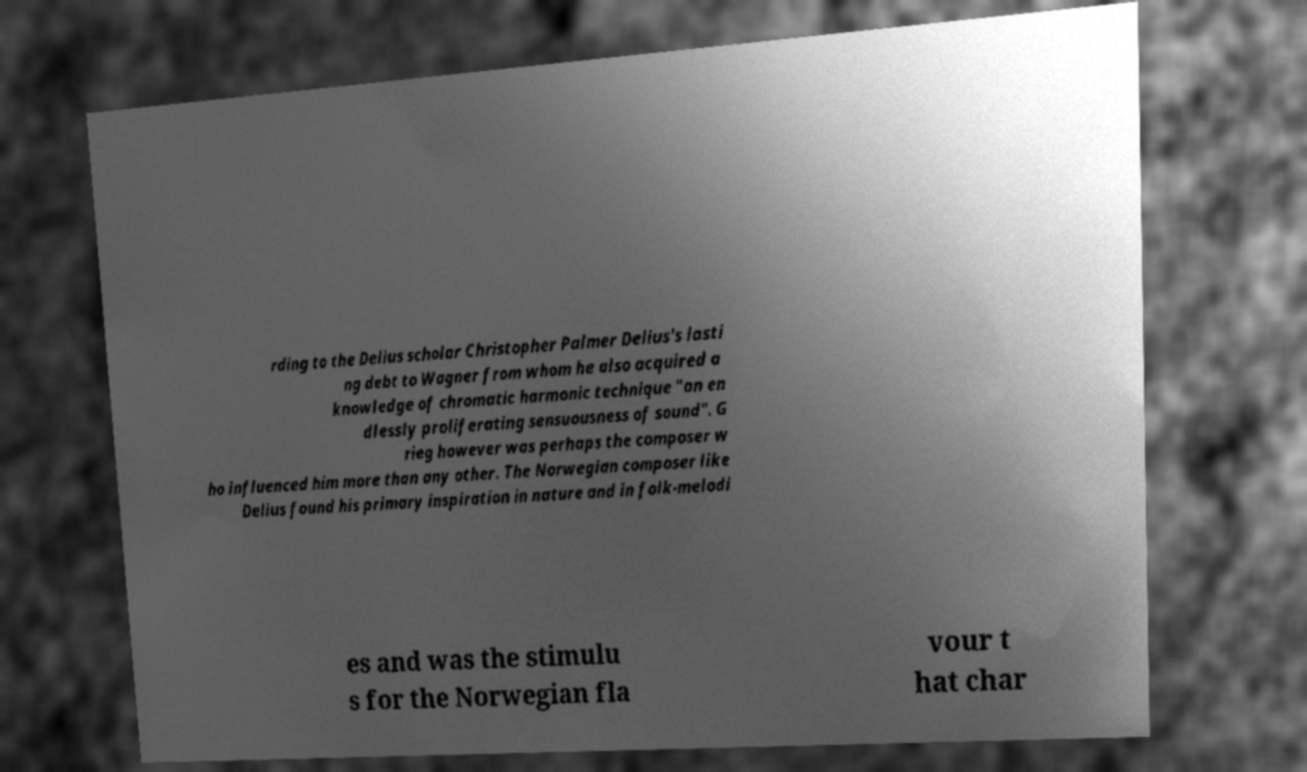For documentation purposes, I need the text within this image transcribed. Could you provide that? rding to the Delius scholar Christopher Palmer Delius's lasti ng debt to Wagner from whom he also acquired a knowledge of chromatic harmonic technique "an en dlessly proliferating sensuousness of sound". G rieg however was perhaps the composer w ho influenced him more than any other. The Norwegian composer like Delius found his primary inspiration in nature and in folk-melodi es and was the stimulu s for the Norwegian fla vour t hat char 